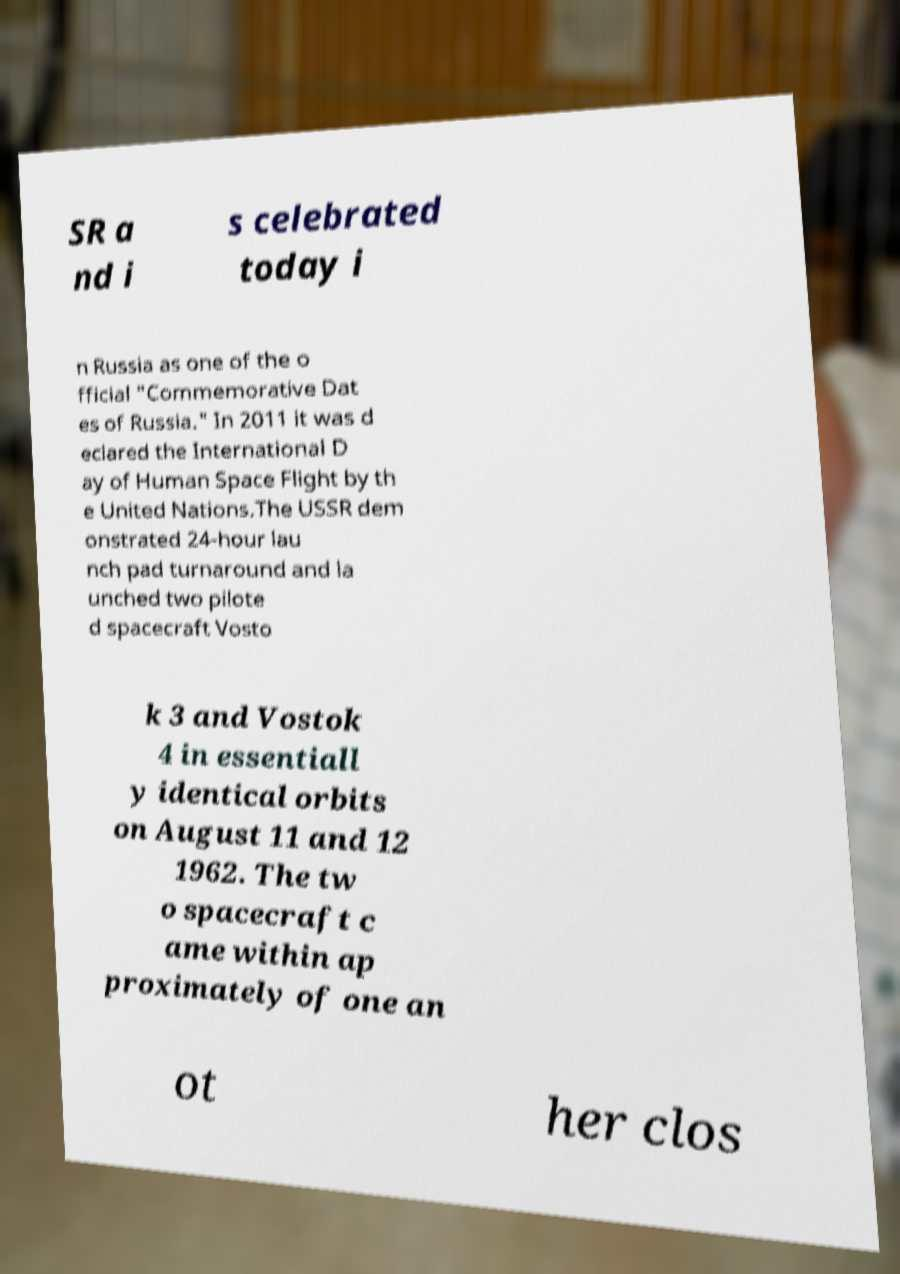Please read and relay the text visible in this image. What does it say? SR a nd i s celebrated today i n Russia as one of the o fficial "Commemorative Dat es of Russia." In 2011 it was d eclared the International D ay of Human Space Flight by th e United Nations.The USSR dem onstrated 24-hour lau nch pad turnaround and la unched two pilote d spacecraft Vosto k 3 and Vostok 4 in essentiall y identical orbits on August 11 and 12 1962. The tw o spacecraft c ame within ap proximately of one an ot her clos 